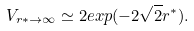<formula> <loc_0><loc_0><loc_500><loc_500>V _ { r * \to \infty } \simeq 2 e x p ( - 2 \sqrt { 2 } r ^ { * } ) .</formula> 